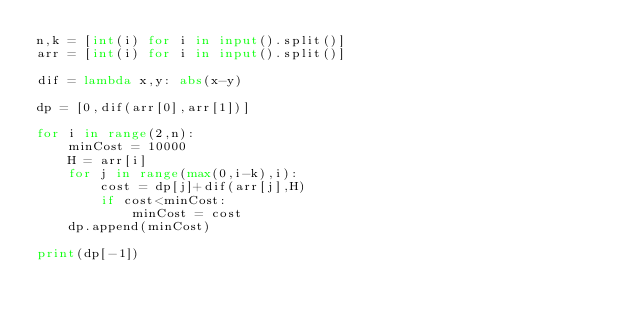Convert code to text. <code><loc_0><loc_0><loc_500><loc_500><_Python_>n,k = [int(i) for i in input().split()]
arr = [int(i) for i in input().split()]

dif = lambda x,y: abs(x-y)

dp = [0,dif(arr[0],arr[1])]

for i in range(2,n):
    minCost = 10000
    H = arr[i]
    for j in range(max(0,i-k),i):
        cost = dp[j]+dif(arr[j],H)
        if cost<minCost:
            minCost = cost
    dp.append(minCost)

print(dp[-1])
</code> 